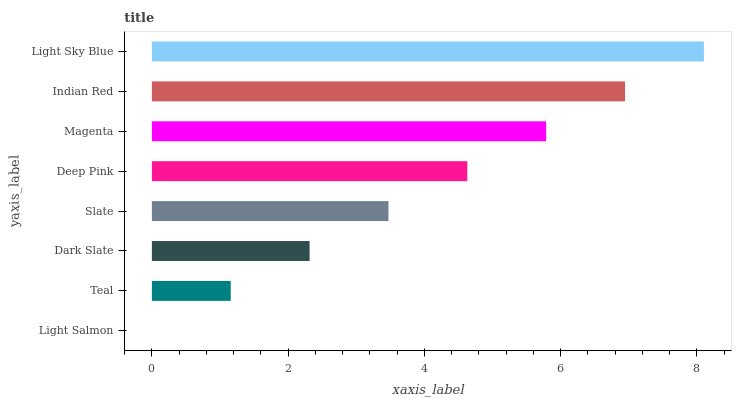Is Light Salmon the minimum?
Answer yes or no. Yes. Is Light Sky Blue the maximum?
Answer yes or no. Yes. Is Teal the minimum?
Answer yes or no. No. Is Teal the maximum?
Answer yes or no. No. Is Teal greater than Light Salmon?
Answer yes or no. Yes. Is Light Salmon less than Teal?
Answer yes or no. Yes. Is Light Salmon greater than Teal?
Answer yes or no. No. Is Teal less than Light Salmon?
Answer yes or no. No. Is Deep Pink the high median?
Answer yes or no. Yes. Is Slate the low median?
Answer yes or no. Yes. Is Dark Slate the high median?
Answer yes or no. No. Is Teal the low median?
Answer yes or no. No. 